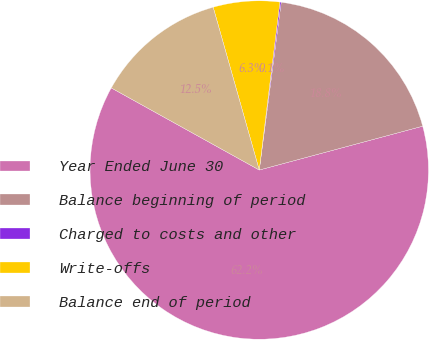Convert chart. <chart><loc_0><loc_0><loc_500><loc_500><pie_chart><fcel>Year Ended June 30<fcel>Balance beginning of period<fcel>Charged to costs and other<fcel>Write-offs<fcel>Balance end of period<nl><fcel>62.24%<fcel>18.76%<fcel>0.12%<fcel>6.34%<fcel>12.55%<nl></chart> 